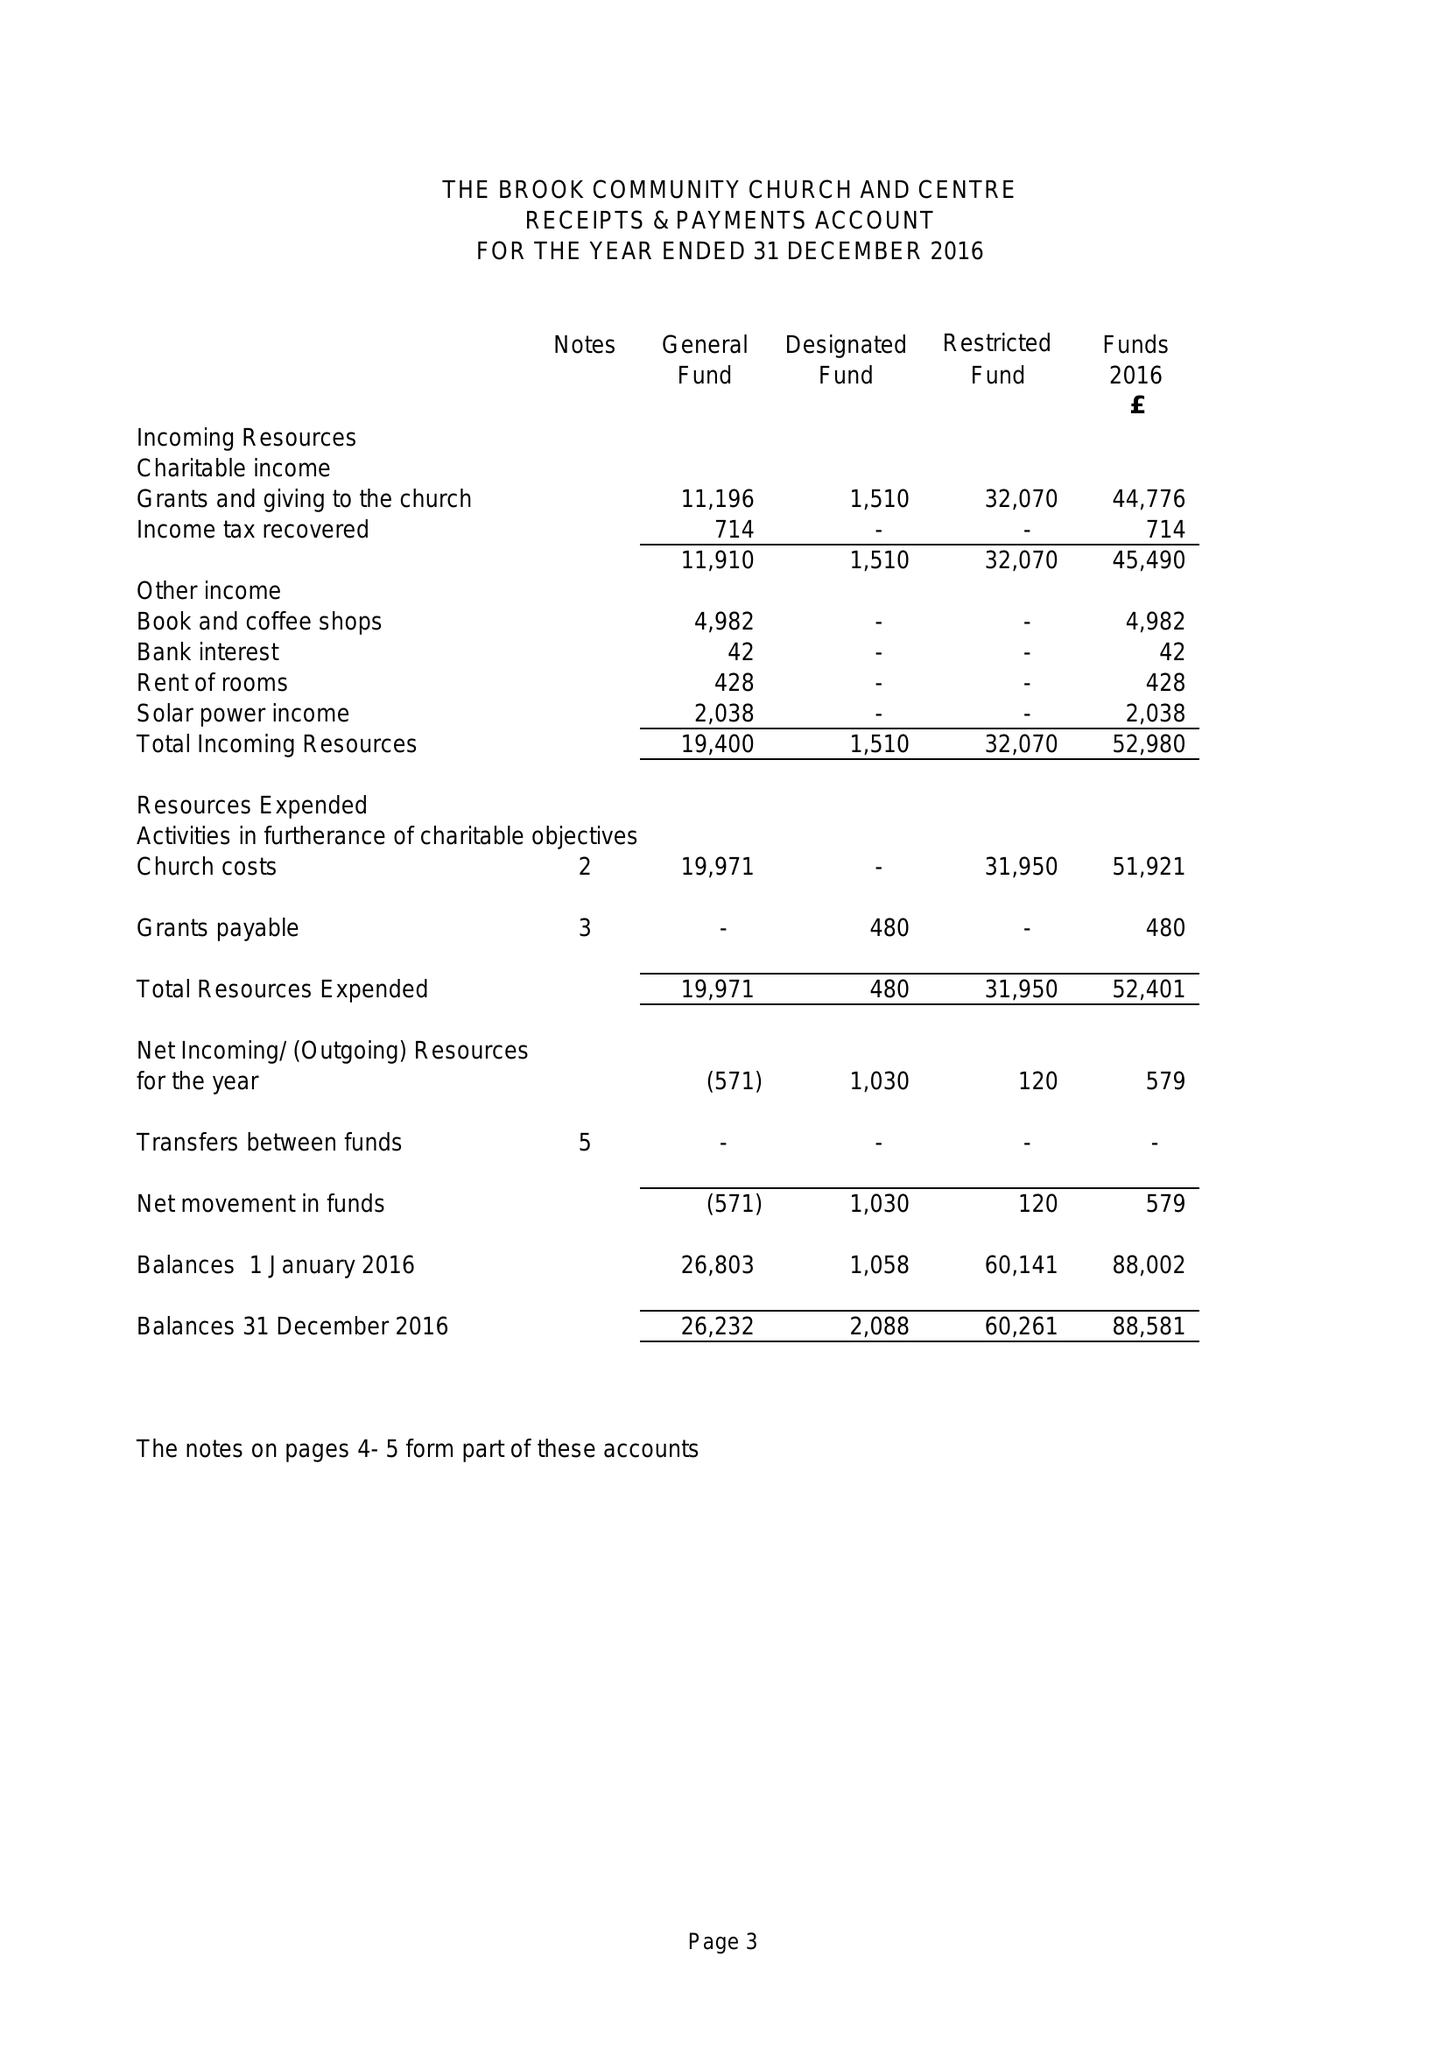What is the value for the report_date?
Answer the question using a single word or phrase. 2016-12-31 